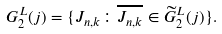<formula> <loc_0><loc_0><loc_500><loc_500>G ^ { L } _ { 2 } ( j ) = \{ J _ { n , k } \colon \overline { J _ { n , k } } \in \widetilde { G } ^ { L } _ { 2 } ( j ) \} .</formula> 